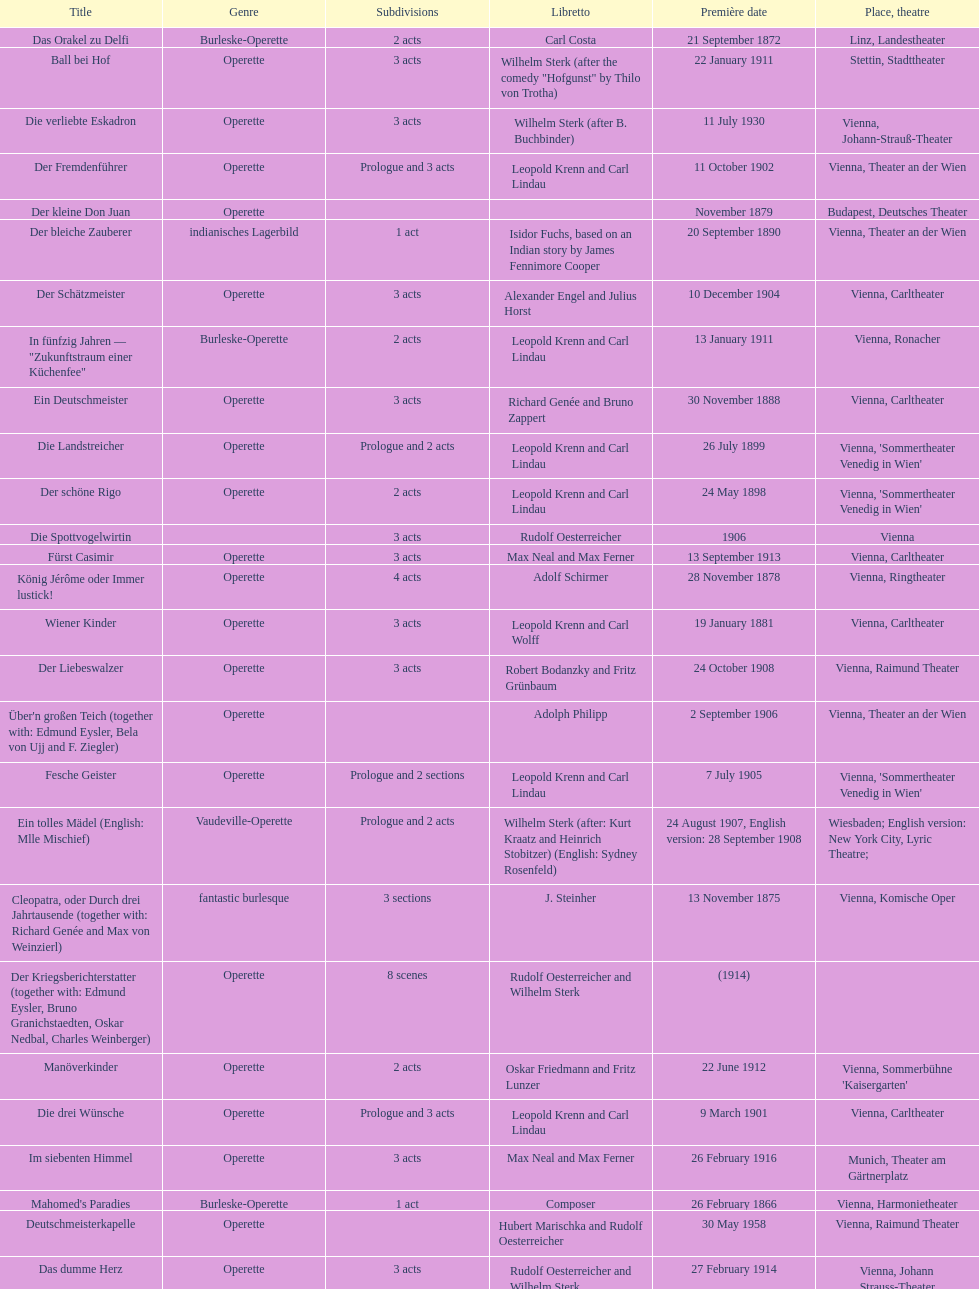How many number of 1 acts were there? 5. 